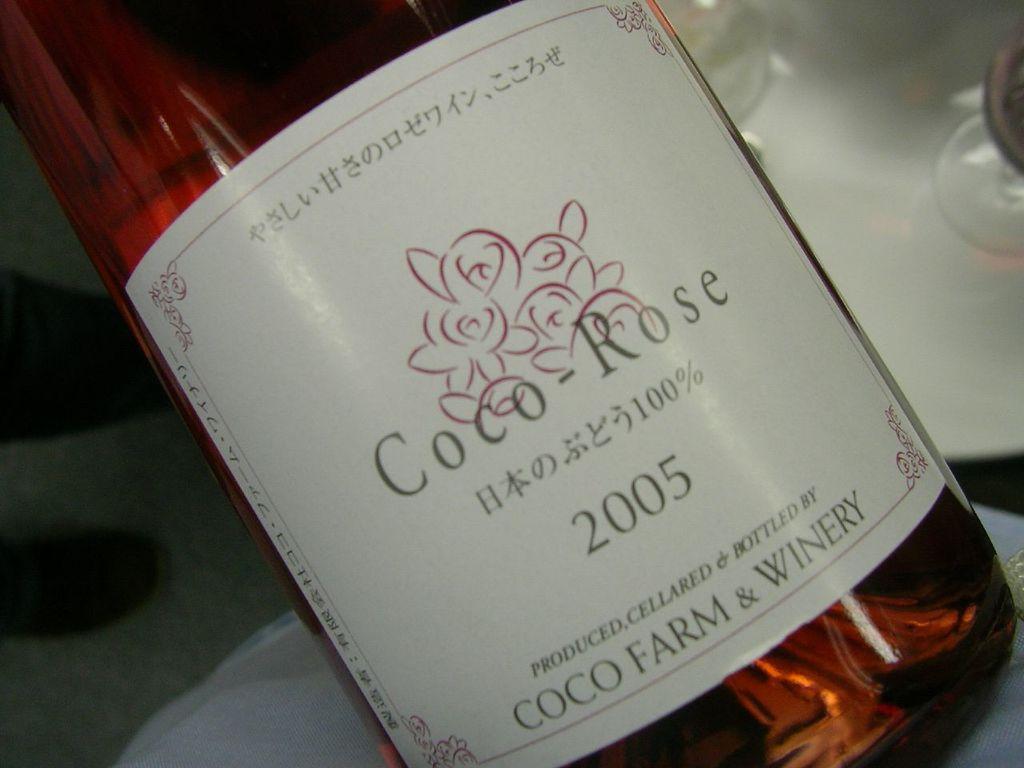Describe this image in one or two sentences. In this image I can see a bottle which is red in color and a white colored sticker attached to the bottle. I can see few glasses, a white colored object and few black colored objects in the background. 